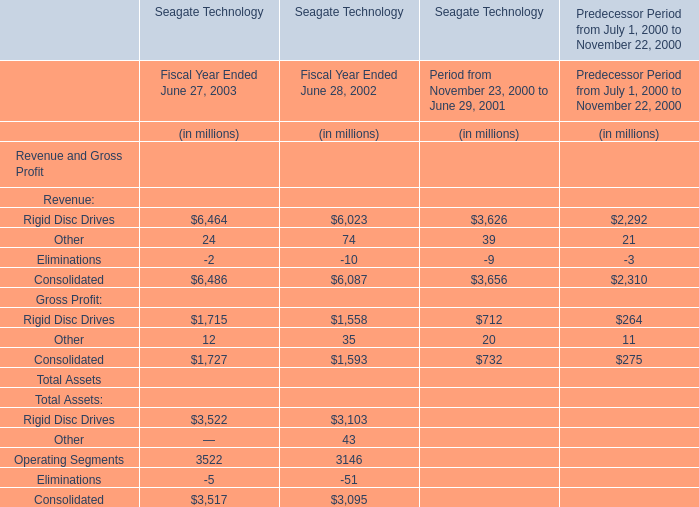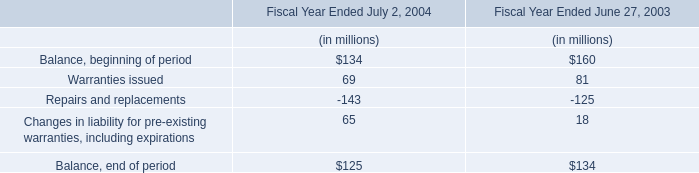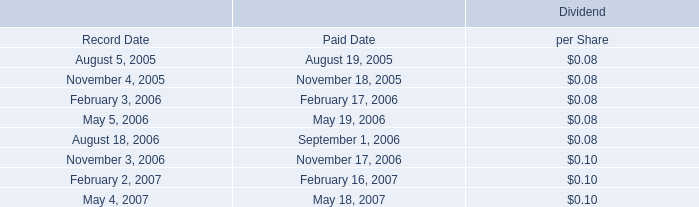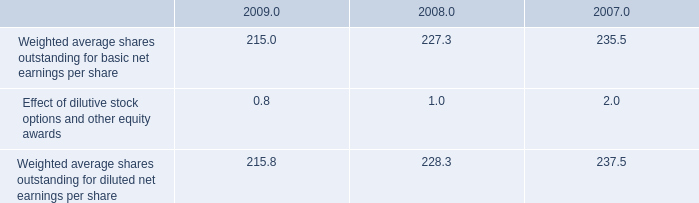What will Consolidated for Revenue and Gross Profit be like in 2004 if it develops with the same increasing rate as current? (in million) 
Computations: ((1 + ((6486 - 6087) / 6087)) * 6486)
Answer: 6911.15426. 